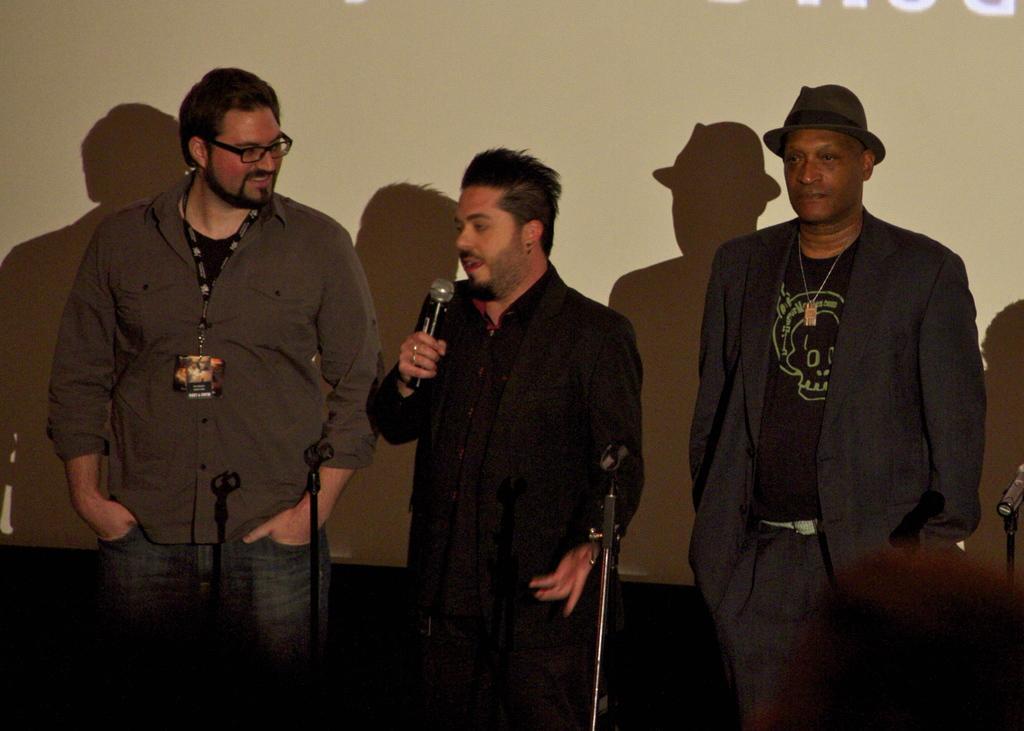Could you give a brief overview of what you see in this image? Here we can see a three persons who are standing. The person in the center is holding a microphone in his hand and he is speaking and the person on the left side is smiling. 